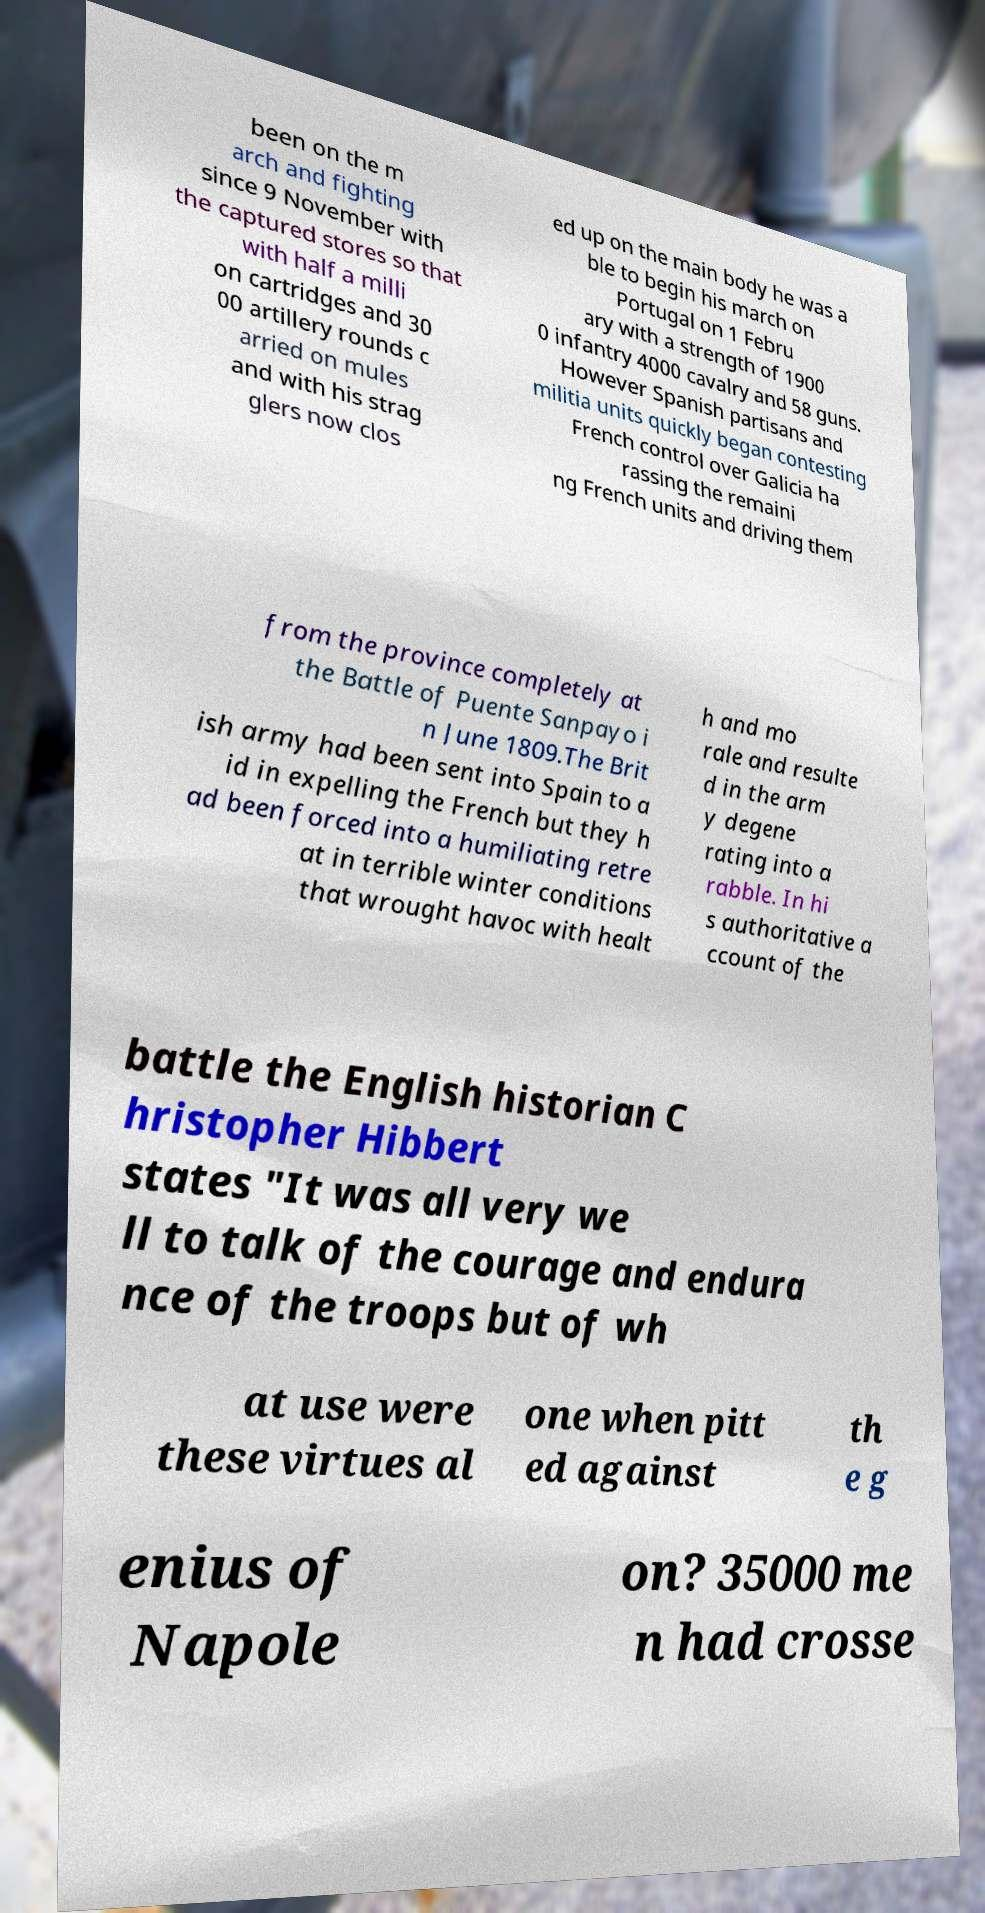I need the written content from this picture converted into text. Can you do that? been on the m arch and fighting since 9 November with the captured stores so that with half a milli on cartridges and 30 00 artillery rounds c arried on mules and with his strag glers now clos ed up on the main body he was a ble to begin his march on Portugal on 1 Febru ary with a strength of 1900 0 infantry 4000 cavalry and 58 guns. However Spanish partisans and militia units quickly began contesting French control over Galicia ha rassing the remaini ng French units and driving them from the province completely at the Battle of Puente Sanpayo i n June 1809.The Brit ish army had been sent into Spain to a id in expelling the French but they h ad been forced into a humiliating retre at in terrible winter conditions that wrought havoc with healt h and mo rale and resulte d in the arm y degene rating into a rabble. In hi s authoritative a ccount of the battle the English historian C hristopher Hibbert states "It was all very we ll to talk of the courage and endura nce of the troops but of wh at use were these virtues al one when pitt ed against th e g enius of Napole on? 35000 me n had crosse 